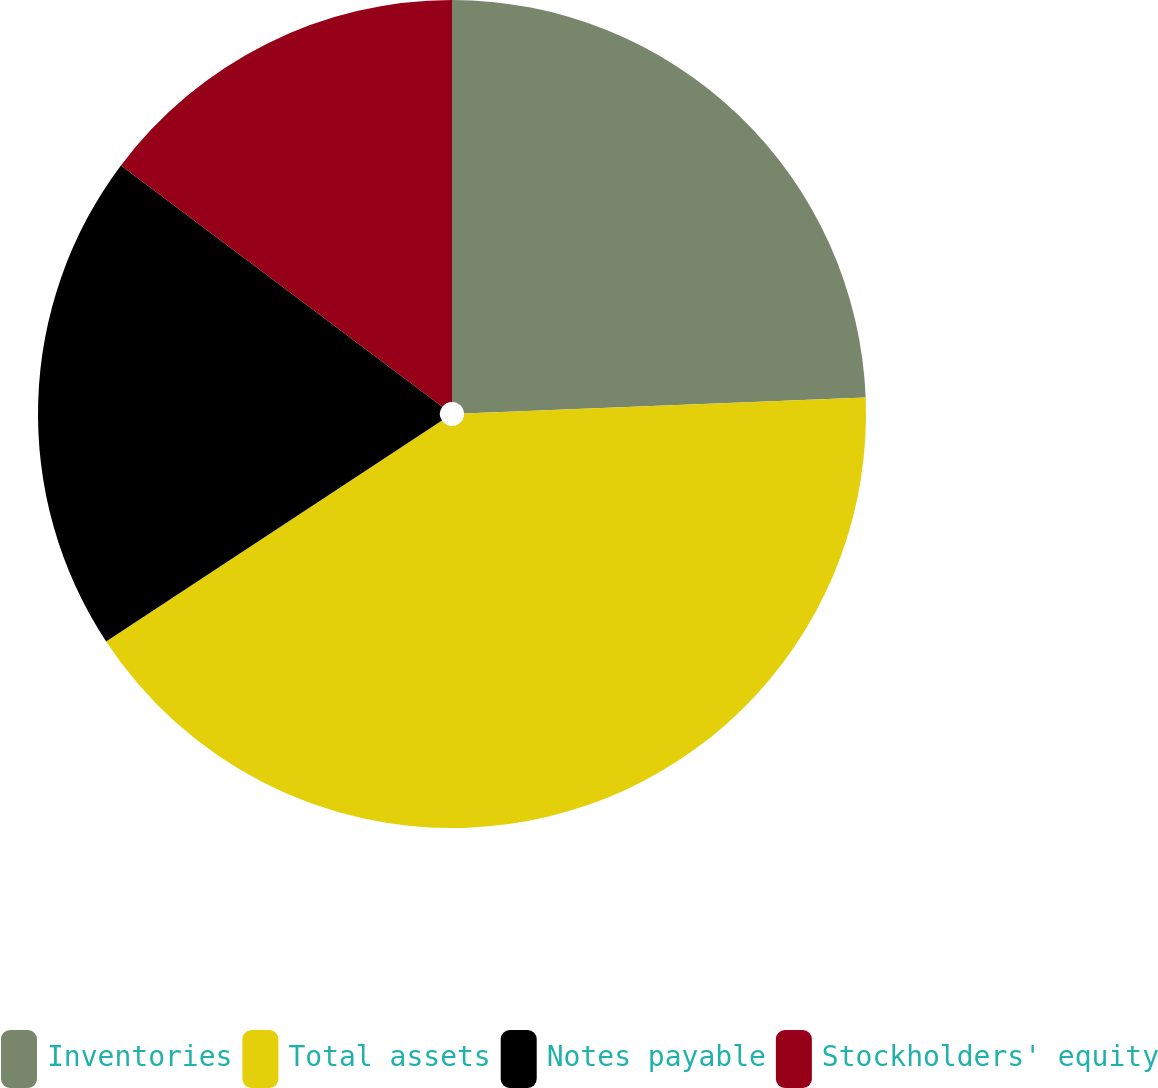Convert chart. <chart><loc_0><loc_0><loc_500><loc_500><pie_chart><fcel>Inventories<fcel>Total assets<fcel>Notes payable<fcel>Stockholders' equity<nl><fcel>24.37%<fcel>41.37%<fcel>19.51%<fcel>14.75%<nl></chart> 